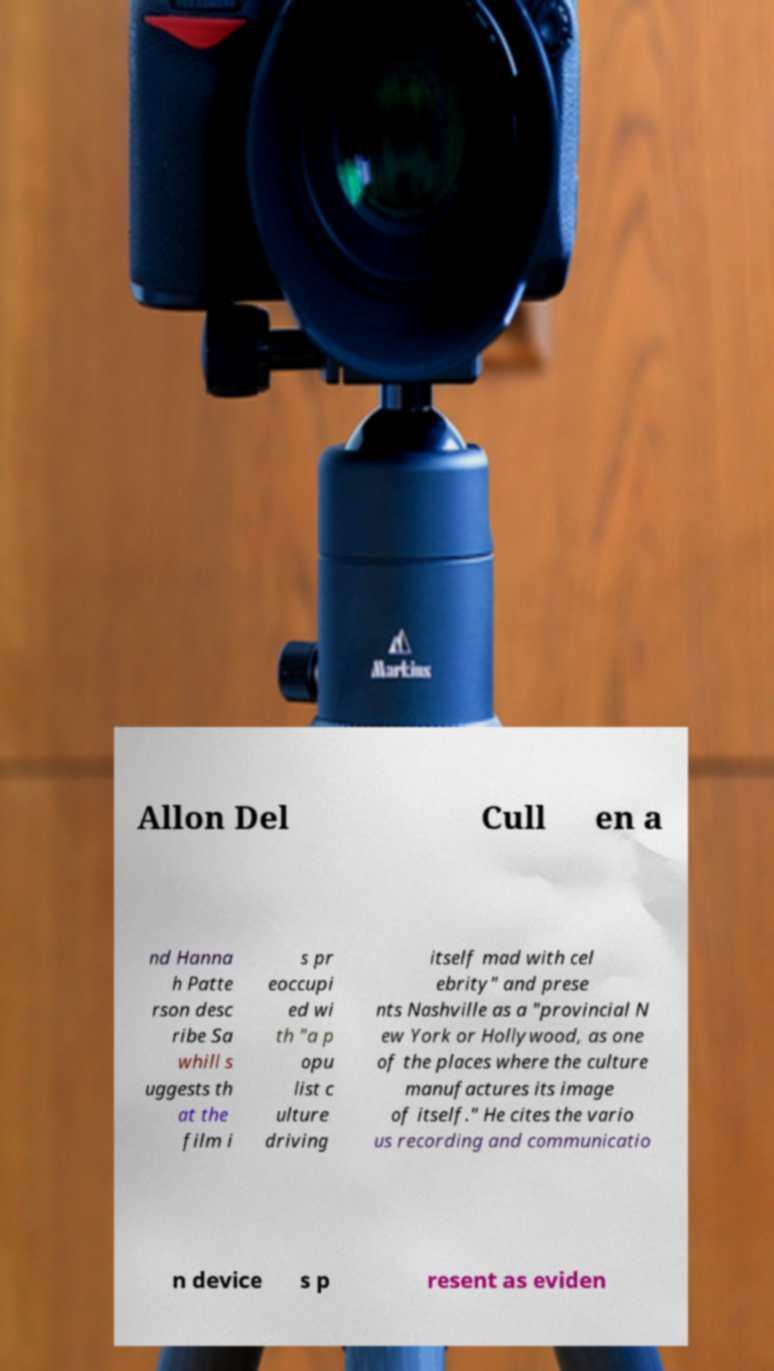What messages or text are displayed in this image? I need them in a readable, typed format. Allon Del Cull en a nd Hanna h Patte rson desc ribe Sa whill s uggests th at the film i s pr eoccupi ed wi th "a p opu list c ulture driving itself mad with cel ebrity" and prese nts Nashville as a "provincial N ew York or Hollywood, as one of the places where the culture manufactures its image of itself." He cites the vario us recording and communicatio n device s p resent as eviden 